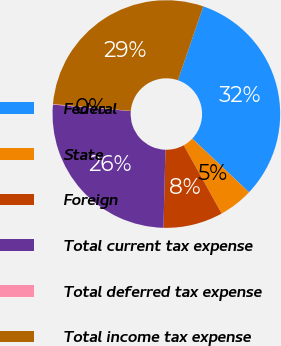Convert chart to OTSL. <chart><loc_0><loc_0><loc_500><loc_500><pie_chart><fcel>Federal<fcel>State<fcel>Foreign<fcel>Total current tax expense<fcel>Total deferred tax expense<fcel>Total income tax expense<nl><fcel>31.81%<fcel>4.86%<fcel>8.48%<fcel>25.92%<fcel>0.08%<fcel>28.86%<nl></chart> 